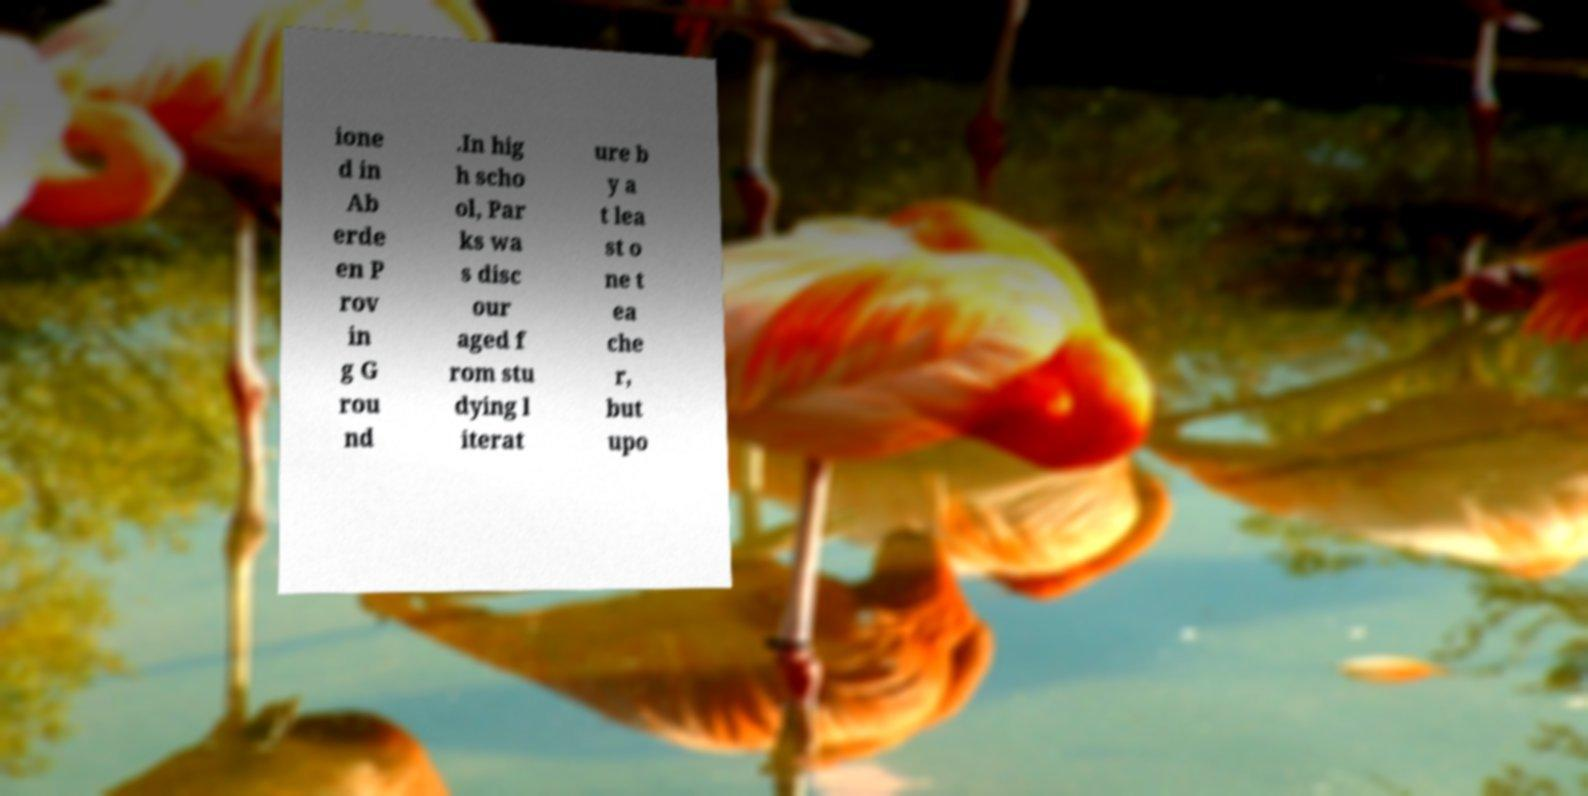For documentation purposes, I need the text within this image transcribed. Could you provide that? ione d in Ab erde en P rov in g G rou nd .In hig h scho ol, Par ks wa s disc our aged f rom stu dying l iterat ure b y a t lea st o ne t ea che r, but upo 